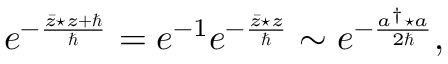Convert formula to latex. <formula><loc_0><loc_0><loc_500><loc_500>e ^ { - \frac { \bar { z } ^ { * } z + } { } } = e ^ { - 1 } e ^ { - \frac { \bar { z } ^ { * } z } { } } \sim e ^ { - \frac { a ^ { \dagger } ^ { * } a } { 2 } } ,</formula> 